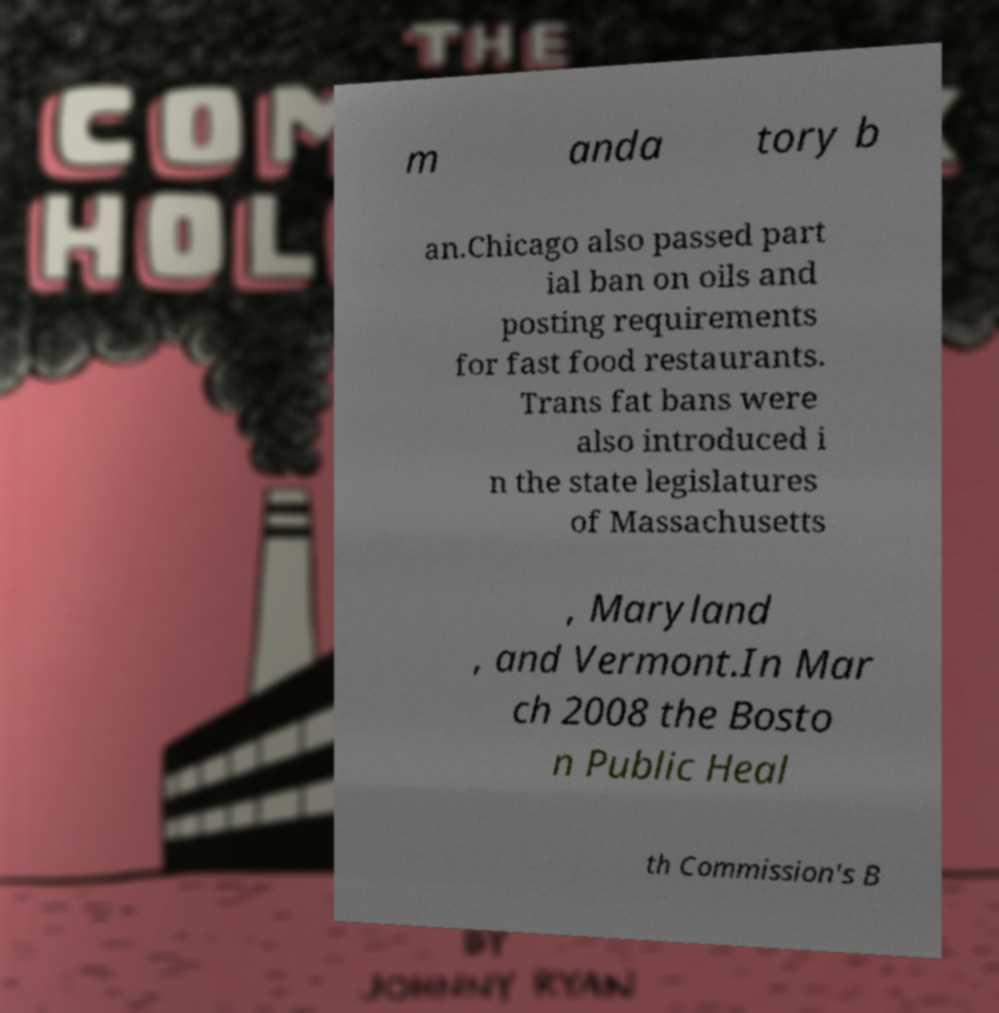Please identify and transcribe the text found in this image. m anda tory b an.Chicago also passed part ial ban on oils and posting requirements for fast food restaurants. Trans fat bans were also introduced i n the state legislatures of Massachusetts , Maryland , and Vermont.In Mar ch 2008 the Bosto n Public Heal th Commission's B 